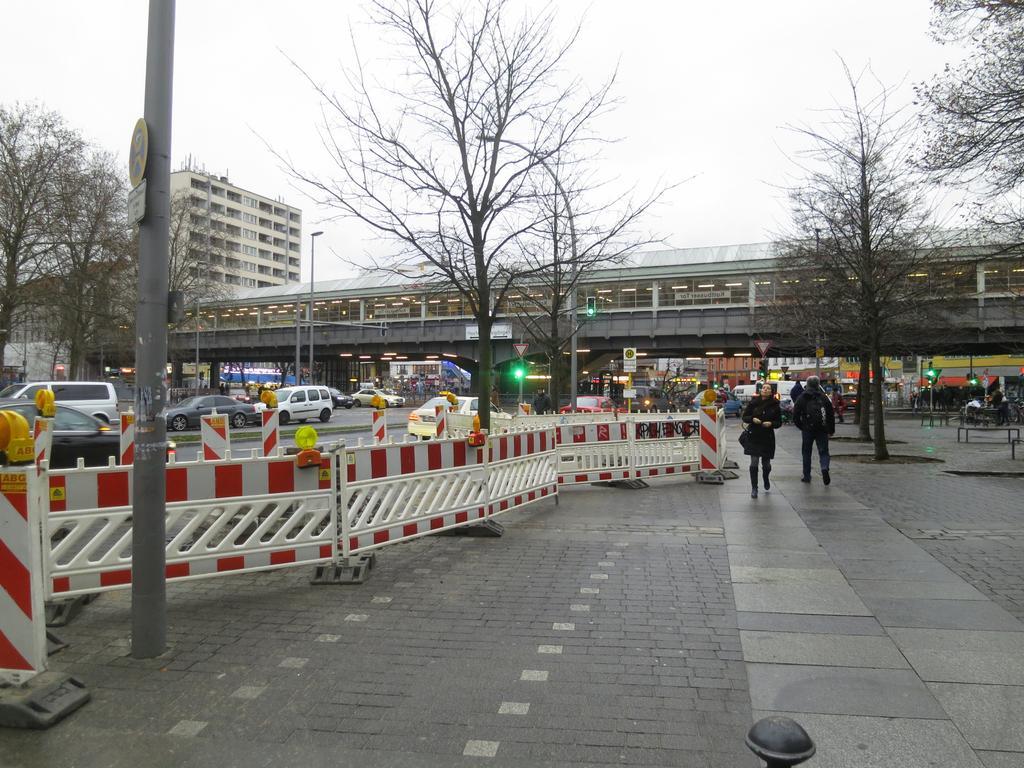Can you describe this image briefly? In this image I can see few people walking. To the side of these people I can see the dividers, many trees and the vehicles on the road. In the background I can see the light pole and the bridge. I can also see the building and the sky in the back. 